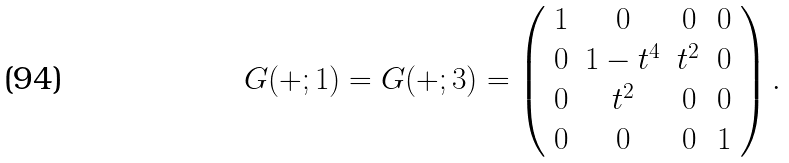<formula> <loc_0><loc_0><loc_500><loc_500>G ( + ; 1 ) = G ( + ; 3 ) = \left ( \begin{array} { c c c c } 1 & 0 & 0 & 0 \\ 0 & 1 - t ^ { 4 } & t ^ { 2 } & 0 \\ 0 & t ^ { 2 } & 0 & 0 \\ 0 & 0 & 0 & 1 \end{array} \right ) . \\</formula> 